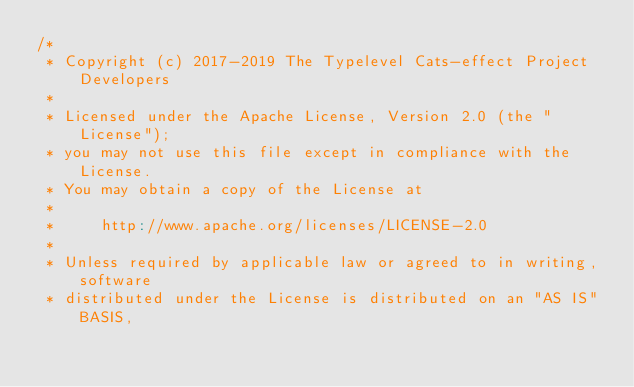Convert code to text. <code><loc_0><loc_0><loc_500><loc_500><_Scala_>/*
 * Copyright (c) 2017-2019 The Typelevel Cats-effect Project Developers
 *
 * Licensed under the Apache License, Version 2.0 (the "License");
 * you may not use this file except in compliance with the License.
 * You may obtain a copy of the License at
 *
 *     http://www.apache.org/licenses/LICENSE-2.0
 *
 * Unless required by applicable law or agreed to in writing, software
 * distributed under the License is distributed on an "AS IS" BASIS,</code> 